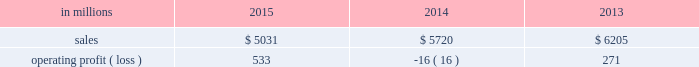Compared with $ 6.2 billion in 2013 .
Operating profits in 2015 were significantly higher than in both 2014 and 2013 .
Excluding facility closure costs , impairment costs and other special items , operating profits in 2015 were 3% ( 3 % ) lower than in 2014 and 4% ( 4 % ) higher than in 2013 .
Benefits from lower input costs ( $ 18 million ) , lower costs associated with the closure of our courtland , alabama mill ( $ 44 million ) and favorable foreign exchange ( $ 33 million ) were offset by lower average sales price realizations and mix ( $ 52 million ) , lower sales volumes ( $ 16 million ) , higher operating costs ( $ 18 million ) and higher planned maintenance downtime costs ( $ 26 million ) .
In addition , operating profits in 2014 include special items costs of $ 554 million associated with the closure of our courtland , alabama mill .
During 2013 , the company accelerated depreciation for certain courtland assets , and evaluated certain other assets for possible alternative uses by one of our other businesses .
The net book value of these assets at december 31 , 2013 was approximately $ 470 million .
In the first quarter of 2014 , we completed our evaluation and concluded that there were no alternative uses for these assets .
We recognized approximately $ 464 million of accelerated depreciation related to these assets in 2014 .
Operating profits in 2014 also include a charge of $ 32 million associated with a foreign tax amnesty program , and a gain of $ 20 million for the resolution of a legal contingency in india , while operating profits in 2013 included costs of $ 118 million associated with the announced closure of our courtland , alabama mill and a $ 123 million impairment charge associated with goodwill and a trade name intangible asset in our india papers business .
Printing papers .
North american printing papers net sales were $ 1.9 billion in 2015 , $ 2.1 billion in 2014 and $ 2.6 billion in 2013 .
Operating profits in 2015 were $ 179 million compared with a loss of $ 398 million ( a gain of $ 156 million excluding costs associated with the shutdown of our courtland , alabama mill ) in 2014 and a gain of $ 36 million ( $ 154 million excluding costs associated with the courtland mill shutdown ) in 2013 .
Sales volumes in 2015 decreased compared with 2014 primarily due to the closure of our courtland mill in 2014 .
Shipments to the domestic market increased , but export shipments declined .
Average sales price realizations decreased , primarily in the domestic market .
Input costs were lower , mainly for energy .
Planned maintenance downtime costs were $ 12 million higher in 2015 .
Operating profits in 2014 were negatively impacted by costs associated with the shutdown of our courtland , alabama mill .
Entering the first quarter of 2016 , sales volumes are expected to be up slightly compared with the fourth quarter of 2015 .
Average sales margins should be about flat reflecting lower average sales price realizations offset by a more favorable product mix .
Input costs are expected to be stable .
Planned maintenance downtime costs are expected to be about $ 14 million lower with an outage scheduled in the 2016 first quarter at our georgetown mill compared with outages at our eastover and riverdale mills in the 2015 fourth quarter .
In january 2015 , the united steelworkers , domtar corporation , packaging corporation of america , finch paper llc and p .
Glatfelter company ( the petitioners ) filed an anti-dumping petition before the united states international trade commission ( itc ) and the united states department of commerce ( doc ) alleging that paper producers in china , indonesia , australia , brazil , and portugal are selling uncoated free sheet paper in sheet form ( the products ) in violation of international trade rules .
The petitioners also filed a countervailing-duties petition with these agencies regarding imports of the products from china and indonesia .
In january 2016 , the doc announced its final countervailing duty rates on imports of the products to the united states from certain producers from china and indonesia .
Also , in january 2016 , the doc announced its final anti-dumping duty rates on imports of the products to the united states from certain producers from australia , brazil , china , indonesia and portugal .
In february 2016 , the itc concluded its anti- dumping and countervailing duties investigations and made a final determination that the u.s .
Market had been injured by imports of the products .
Accordingly , the doc 2019s previously announced countervailing duty rates and anti-dumping duty rates will be in effect for a minimum of five years .
We do not believe the impact of these rates will have a material , adverse effect on our consolidated financial statements .
Brazilian papers net sales for 2015 were $ 878 million compared with $ 1.1 billion in 2014 and $ 1.1 billion in 2013 .
Operating profits for 2015 were $ 186 million compared with $ 177 million ( $ 209 million excluding costs associated with a tax amnesty program ) in 2014 and $ 210 million in 2013 .
Sales volumes in 2015 were lower compared with 2014 reflecting weak economic conditions and the absence of 2014 one-time events .
Average sales price realizations improved for domestic uncoated freesheet paper due to the realization of price increases implemented in the second half of 2015 .
Margins were unfavorably affected by an increased proportion of sales to the lower-margin export markets .
Raw material costs increased for energy and wood .
Operating costs were higher than in 2014 , while planned maintenance downtime costs were $ 4 million lower. .
What percentage of printing paper sales where north american printing papers net sales 2014? 
Computations: ((2.1 * 1000) / 5720)
Answer: 0.36713. 